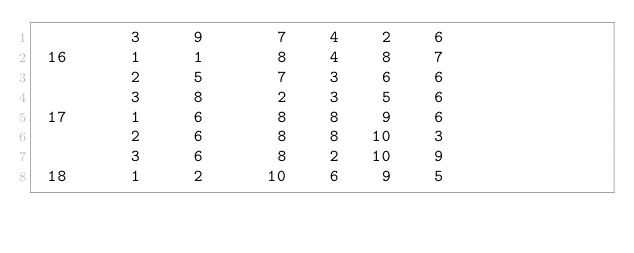<code> <loc_0><loc_0><loc_500><loc_500><_ObjectiveC_>         3     9       7    4    2    6
 16      1     1       8    4    8    7
         2     5       7    3    6    6
         3     8       2    3    5    6
 17      1     6       8    8    9    6
         2     6       8    8   10    3
         3     6       8    2   10    9
 18      1     2      10    6    9    5</code> 